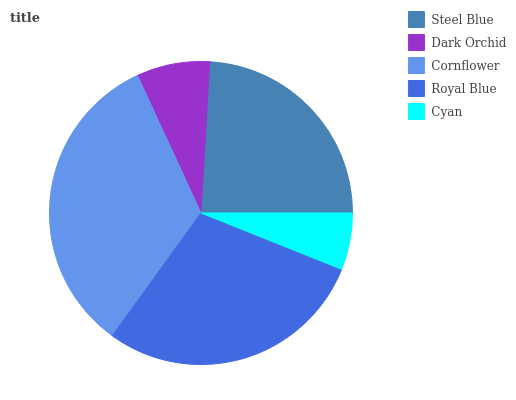Is Cyan the minimum?
Answer yes or no. Yes. Is Cornflower the maximum?
Answer yes or no. Yes. Is Dark Orchid the minimum?
Answer yes or no. No. Is Dark Orchid the maximum?
Answer yes or no. No. Is Steel Blue greater than Dark Orchid?
Answer yes or no. Yes. Is Dark Orchid less than Steel Blue?
Answer yes or no. Yes. Is Dark Orchid greater than Steel Blue?
Answer yes or no. No. Is Steel Blue less than Dark Orchid?
Answer yes or no. No. Is Steel Blue the high median?
Answer yes or no. Yes. Is Steel Blue the low median?
Answer yes or no. Yes. Is Cornflower the high median?
Answer yes or no. No. Is Royal Blue the low median?
Answer yes or no. No. 